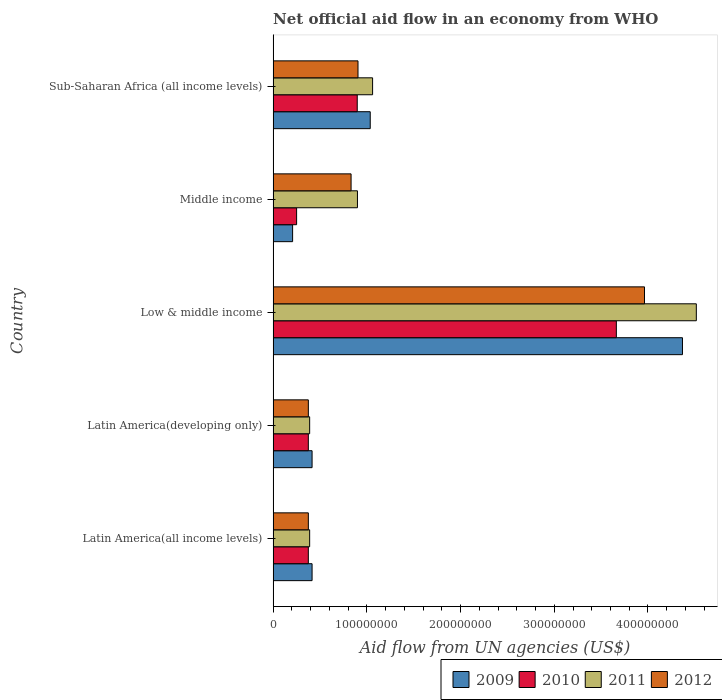How many groups of bars are there?
Offer a very short reply. 5. Are the number of bars per tick equal to the number of legend labels?
Your answer should be very brief. Yes. Are the number of bars on each tick of the Y-axis equal?
Your response must be concise. Yes. How many bars are there on the 2nd tick from the bottom?
Your response must be concise. 4. In how many cases, is the number of bars for a given country not equal to the number of legend labels?
Provide a short and direct response. 0. What is the net official aid flow in 2010 in Latin America(all income levels)?
Keep it short and to the point. 3.76e+07. Across all countries, what is the maximum net official aid flow in 2011?
Provide a short and direct response. 4.52e+08. Across all countries, what is the minimum net official aid flow in 2009?
Make the answer very short. 2.08e+07. In which country was the net official aid flow in 2012 maximum?
Provide a short and direct response. Low & middle income. In which country was the net official aid flow in 2011 minimum?
Provide a short and direct response. Latin America(all income levels). What is the total net official aid flow in 2009 in the graph?
Offer a very short reply. 6.44e+08. What is the difference between the net official aid flow in 2009 in Low & middle income and that in Middle income?
Ensure brevity in your answer.  4.16e+08. What is the difference between the net official aid flow in 2010 in Sub-Saharan Africa (all income levels) and the net official aid flow in 2012 in Middle income?
Offer a very short reply. 6.58e+06. What is the average net official aid flow in 2011 per country?
Give a very brief answer. 1.45e+08. What is the difference between the net official aid flow in 2010 and net official aid flow in 2009 in Latin America(developing only)?
Provide a short and direct response. -4.01e+06. In how many countries, is the net official aid flow in 2011 greater than 280000000 US$?
Keep it short and to the point. 1. What is the ratio of the net official aid flow in 2012 in Latin America(developing only) to that in Low & middle income?
Make the answer very short. 0.09. What is the difference between the highest and the second highest net official aid flow in 2011?
Make the answer very short. 3.45e+08. What is the difference between the highest and the lowest net official aid flow in 2012?
Provide a succinct answer. 3.59e+08. Are all the bars in the graph horizontal?
Ensure brevity in your answer.  Yes. What is the difference between two consecutive major ticks on the X-axis?
Your answer should be compact. 1.00e+08. Does the graph contain any zero values?
Offer a terse response. No. Does the graph contain grids?
Make the answer very short. No. Where does the legend appear in the graph?
Ensure brevity in your answer.  Bottom right. How are the legend labels stacked?
Your answer should be very brief. Horizontal. What is the title of the graph?
Provide a short and direct response. Net official aid flow in an economy from WHO. Does "1990" appear as one of the legend labels in the graph?
Your response must be concise. No. What is the label or title of the X-axis?
Offer a very short reply. Aid flow from UN agencies (US$). What is the Aid flow from UN agencies (US$) of 2009 in Latin America(all income levels)?
Offer a very short reply. 4.16e+07. What is the Aid flow from UN agencies (US$) in 2010 in Latin America(all income levels)?
Give a very brief answer. 3.76e+07. What is the Aid flow from UN agencies (US$) of 2011 in Latin America(all income levels)?
Offer a terse response. 3.90e+07. What is the Aid flow from UN agencies (US$) of 2012 in Latin America(all income levels)?
Make the answer very short. 3.76e+07. What is the Aid flow from UN agencies (US$) of 2009 in Latin America(developing only)?
Offer a very short reply. 4.16e+07. What is the Aid flow from UN agencies (US$) of 2010 in Latin America(developing only)?
Provide a succinct answer. 3.76e+07. What is the Aid flow from UN agencies (US$) in 2011 in Latin America(developing only)?
Ensure brevity in your answer.  3.90e+07. What is the Aid flow from UN agencies (US$) of 2012 in Latin America(developing only)?
Make the answer very short. 3.76e+07. What is the Aid flow from UN agencies (US$) in 2009 in Low & middle income?
Your answer should be compact. 4.37e+08. What is the Aid flow from UN agencies (US$) of 2010 in Low & middle income?
Provide a succinct answer. 3.66e+08. What is the Aid flow from UN agencies (US$) in 2011 in Low & middle income?
Offer a very short reply. 4.52e+08. What is the Aid flow from UN agencies (US$) of 2012 in Low & middle income?
Keep it short and to the point. 3.96e+08. What is the Aid flow from UN agencies (US$) in 2009 in Middle income?
Provide a succinct answer. 2.08e+07. What is the Aid flow from UN agencies (US$) of 2010 in Middle income?
Give a very brief answer. 2.51e+07. What is the Aid flow from UN agencies (US$) of 2011 in Middle income?
Provide a succinct answer. 9.00e+07. What is the Aid flow from UN agencies (US$) in 2012 in Middle income?
Keep it short and to the point. 8.32e+07. What is the Aid flow from UN agencies (US$) of 2009 in Sub-Saharan Africa (all income levels)?
Give a very brief answer. 1.04e+08. What is the Aid flow from UN agencies (US$) of 2010 in Sub-Saharan Africa (all income levels)?
Make the answer very short. 8.98e+07. What is the Aid flow from UN agencies (US$) of 2011 in Sub-Saharan Africa (all income levels)?
Keep it short and to the point. 1.06e+08. What is the Aid flow from UN agencies (US$) of 2012 in Sub-Saharan Africa (all income levels)?
Provide a succinct answer. 9.06e+07. Across all countries, what is the maximum Aid flow from UN agencies (US$) of 2009?
Offer a terse response. 4.37e+08. Across all countries, what is the maximum Aid flow from UN agencies (US$) in 2010?
Give a very brief answer. 3.66e+08. Across all countries, what is the maximum Aid flow from UN agencies (US$) of 2011?
Provide a succinct answer. 4.52e+08. Across all countries, what is the maximum Aid flow from UN agencies (US$) of 2012?
Offer a terse response. 3.96e+08. Across all countries, what is the minimum Aid flow from UN agencies (US$) in 2009?
Your response must be concise. 2.08e+07. Across all countries, what is the minimum Aid flow from UN agencies (US$) in 2010?
Your answer should be compact. 2.51e+07. Across all countries, what is the minimum Aid flow from UN agencies (US$) of 2011?
Your answer should be very brief. 3.90e+07. Across all countries, what is the minimum Aid flow from UN agencies (US$) in 2012?
Your answer should be very brief. 3.76e+07. What is the total Aid flow from UN agencies (US$) in 2009 in the graph?
Your response must be concise. 6.44e+08. What is the total Aid flow from UN agencies (US$) of 2010 in the graph?
Your response must be concise. 5.56e+08. What is the total Aid flow from UN agencies (US$) in 2011 in the graph?
Keep it short and to the point. 7.26e+08. What is the total Aid flow from UN agencies (US$) of 2012 in the graph?
Provide a short and direct response. 6.45e+08. What is the difference between the Aid flow from UN agencies (US$) of 2011 in Latin America(all income levels) and that in Latin America(developing only)?
Make the answer very short. 0. What is the difference between the Aid flow from UN agencies (US$) in 2009 in Latin America(all income levels) and that in Low & middle income?
Make the answer very short. -3.95e+08. What is the difference between the Aid flow from UN agencies (US$) of 2010 in Latin America(all income levels) and that in Low & middle income?
Your answer should be compact. -3.29e+08. What is the difference between the Aid flow from UN agencies (US$) of 2011 in Latin America(all income levels) and that in Low & middle income?
Your response must be concise. -4.13e+08. What is the difference between the Aid flow from UN agencies (US$) in 2012 in Latin America(all income levels) and that in Low & middle income?
Offer a terse response. -3.59e+08. What is the difference between the Aid flow from UN agencies (US$) of 2009 in Latin America(all income levels) and that in Middle income?
Your answer should be compact. 2.08e+07. What is the difference between the Aid flow from UN agencies (US$) of 2010 in Latin America(all income levels) and that in Middle income?
Provide a short and direct response. 1.25e+07. What is the difference between the Aid flow from UN agencies (US$) in 2011 in Latin America(all income levels) and that in Middle income?
Offer a terse response. -5.10e+07. What is the difference between the Aid flow from UN agencies (US$) in 2012 in Latin America(all income levels) and that in Middle income?
Your answer should be very brief. -4.56e+07. What is the difference between the Aid flow from UN agencies (US$) in 2009 in Latin America(all income levels) and that in Sub-Saharan Africa (all income levels)?
Offer a very short reply. -6.20e+07. What is the difference between the Aid flow from UN agencies (US$) in 2010 in Latin America(all income levels) and that in Sub-Saharan Africa (all income levels)?
Your answer should be very brief. -5.22e+07. What is the difference between the Aid flow from UN agencies (US$) in 2011 in Latin America(all income levels) and that in Sub-Saharan Africa (all income levels)?
Your answer should be compact. -6.72e+07. What is the difference between the Aid flow from UN agencies (US$) of 2012 in Latin America(all income levels) and that in Sub-Saharan Africa (all income levels)?
Your answer should be very brief. -5.30e+07. What is the difference between the Aid flow from UN agencies (US$) in 2009 in Latin America(developing only) and that in Low & middle income?
Provide a short and direct response. -3.95e+08. What is the difference between the Aid flow from UN agencies (US$) of 2010 in Latin America(developing only) and that in Low & middle income?
Keep it short and to the point. -3.29e+08. What is the difference between the Aid flow from UN agencies (US$) of 2011 in Latin America(developing only) and that in Low & middle income?
Offer a very short reply. -4.13e+08. What is the difference between the Aid flow from UN agencies (US$) in 2012 in Latin America(developing only) and that in Low & middle income?
Give a very brief answer. -3.59e+08. What is the difference between the Aid flow from UN agencies (US$) in 2009 in Latin America(developing only) and that in Middle income?
Keep it short and to the point. 2.08e+07. What is the difference between the Aid flow from UN agencies (US$) in 2010 in Latin America(developing only) and that in Middle income?
Provide a short and direct response. 1.25e+07. What is the difference between the Aid flow from UN agencies (US$) of 2011 in Latin America(developing only) and that in Middle income?
Provide a short and direct response. -5.10e+07. What is the difference between the Aid flow from UN agencies (US$) of 2012 in Latin America(developing only) and that in Middle income?
Offer a terse response. -4.56e+07. What is the difference between the Aid flow from UN agencies (US$) of 2009 in Latin America(developing only) and that in Sub-Saharan Africa (all income levels)?
Ensure brevity in your answer.  -6.20e+07. What is the difference between the Aid flow from UN agencies (US$) in 2010 in Latin America(developing only) and that in Sub-Saharan Africa (all income levels)?
Offer a terse response. -5.22e+07. What is the difference between the Aid flow from UN agencies (US$) in 2011 in Latin America(developing only) and that in Sub-Saharan Africa (all income levels)?
Offer a very short reply. -6.72e+07. What is the difference between the Aid flow from UN agencies (US$) in 2012 in Latin America(developing only) and that in Sub-Saharan Africa (all income levels)?
Provide a short and direct response. -5.30e+07. What is the difference between the Aid flow from UN agencies (US$) in 2009 in Low & middle income and that in Middle income?
Your answer should be very brief. 4.16e+08. What is the difference between the Aid flow from UN agencies (US$) of 2010 in Low & middle income and that in Middle income?
Give a very brief answer. 3.41e+08. What is the difference between the Aid flow from UN agencies (US$) in 2011 in Low & middle income and that in Middle income?
Give a very brief answer. 3.62e+08. What is the difference between the Aid flow from UN agencies (US$) of 2012 in Low & middle income and that in Middle income?
Your answer should be very brief. 3.13e+08. What is the difference between the Aid flow from UN agencies (US$) in 2009 in Low & middle income and that in Sub-Saharan Africa (all income levels)?
Offer a very short reply. 3.33e+08. What is the difference between the Aid flow from UN agencies (US$) in 2010 in Low & middle income and that in Sub-Saharan Africa (all income levels)?
Offer a very short reply. 2.76e+08. What is the difference between the Aid flow from UN agencies (US$) in 2011 in Low & middle income and that in Sub-Saharan Africa (all income levels)?
Your answer should be very brief. 3.45e+08. What is the difference between the Aid flow from UN agencies (US$) in 2012 in Low & middle income and that in Sub-Saharan Africa (all income levels)?
Ensure brevity in your answer.  3.06e+08. What is the difference between the Aid flow from UN agencies (US$) of 2009 in Middle income and that in Sub-Saharan Africa (all income levels)?
Your response must be concise. -8.28e+07. What is the difference between the Aid flow from UN agencies (US$) of 2010 in Middle income and that in Sub-Saharan Africa (all income levels)?
Offer a very short reply. -6.47e+07. What is the difference between the Aid flow from UN agencies (US$) in 2011 in Middle income and that in Sub-Saharan Africa (all income levels)?
Your response must be concise. -1.62e+07. What is the difference between the Aid flow from UN agencies (US$) in 2012 in Middle income and that in Sub-Saharan Africa (all income levels)?
Your answer should be very brief. -7.39e+06. What is the difference between the Aid flow from UN agencies (US$) in 2009 in Latin America(all income levels) and the Aid flow from UN agencies (US$) in 2010 in Latin America(developing only)?
Keep it short and to the point. 4.01e+06. What is the difference between the Aid flow from UN agencies (US$) of 2009 in Latin America(all income levels) and the Aid flow from UN agencies (US$) of 2011 in Latin America(developing only)?
Your answer should be very brief. 2.59e+06. What is the difference between the Aid flow from UN agencies (US$) of 2009 in Latin America(all income levels) and the Aid flow from UN agencies (US$) of 2012 in Latin America(developing only)?
Keep it short and to the point. 3.99e+06. What is the difference between the Aid flow from UN agencies (US$) of 2010 in Latin America(all income levels) and the Aid flow from UN agencies (US$) of 2011 in Latin America(developing only)?
Your answer should be very brief. -1.42e+06. What is the difference between the Aid flow from UN agencies (US$) in 2011 in Latin America(all income levels) and the Aid flow from UN agencies (US$) in 2012 in Latin America(developing only)?
Ensure brevity in your answer.  1.40e+06. What is the difference between the Aid flow from UN agencies (US$) in 2009 in Latin America(all income levels) and the Aid flow from UN agencies (US$) in 2010 in Low & middle income?
Your answer should be compact. -3.25e+08. What is the difference between the Aid flow from UN agencies (US$) of 2009 in Latin America(all income levels) and the Aid flow from UN agencies (US$) of 2011 in Low & middle income?
Keep it short and to the point. -4.10e+08. What is the difference between the Aid flow from UN agencies (US$) of 2009 in Latin America(all income levels) and the Aid flow from UN agencies (US$) of 2012 in Low & middle income?
Keep it short and to the point. -3.55e+08. What is the difference between the Aid flow from UN agencies (US$) in 2010 in Latin America(all income levels) and the Aid flow from UN agencies (US$) in 2011 in Low & middle income?
Ensure brevity in your answer.  -4.14e+08. What is the difference between the Aid flow from UN agencies (US$) of 2010 in Latin America(all income levels) and the Aid flow from UN agencies (US$) of 2012 in Low & middle income?
Keep it short and to the point. -3.59e+08. What is the difference between the Aid flow from UN agencies (US$) in 2011 in Latin America(all income levels) and the Aid flow from UN agencies (US$) in 2012 in Low & middle income?
Offer a very short reply. -3.57e+08. What is the difference between the Aid flow from UN agencies (US$) in 2009 in Latin America(all income levels) and the Aid flow from UN agencies (US$) in 2010 in Middle income?
Provide a succinct answer. 1.65e+07. What is the difference between the Aid flow from UN agencies (US$) of 2009 in Latin America(all income levels) and the Aid flow from UN agencies (US$) of 2011 in Middle income?
Your answer should be very brief. -4.84e+07. What is the difference between the Aid flow from UN agencies (US$) of 2009 in Latin America(all income levels) and the Aid flow from UN agencies (US$) of 2012 in Middle income?
Your answer should be compact. -4.16e+07. What is the difference between the Aid flow from UN agencies (US$) in 2010 in Latin America(all income levels) and the Aid flow from UN agencies (US$) in 2011 in Middle income?
Provide a succinct answer. -5.24e+07. What is the difference between the Aid flow from UN agencies (US$) in 2010 in Latin America(all income levels) and the Aid flow from UN agencies (US$) in 2012 in Middle income?
Your answer should be very brief. -4.56e+07. What is the difference between the Aid flow from UN agencies (US$) in 2011 in Latin America(all income levels) and the Aid flow from UN agencies (US$) in 2012 in Middle income?
Ensure brevity in your answer.  -4.42e+07. What is the difference between the Aid flow from UN agencies (US$) in 2009 in Latin America(all income levels) and the Aid flow from UN agencies (US$) in 2010 in Sub-Saharan Africa (all income levels)?
Your response must be concise. -4.82e+07. What is the difference between the Aid flow from UN agencies (US$) in 2009 in Latin America(all income levels) and the Aid flow from UN agencies (US$) in 2011 in Sub-Saharan Africa (all income levels)?
Your answer should be compact. -6.46e+07. What is the difference between the Aid flow from UN agencies (US$) in 2009 in Latin America(all income levels) and the Aid flow from UN agencies (US$) in 2012 in Sub-Saharan Africa (all income levels)?
Your answer should be very brief. -4.90e+07. What is the difference between the Aid flow from UN agencies (US$) in 2010 in Latin America(all income levels) and the Aid flow from UN agencies (US$) in 2011 in Sub-Saharan Africa (all income levels)?
Your answer should be very brief. -6.86e+07. What is the difference between the Aid flow from UN agencies (US$) in 2010 in Latin America(all income levels) and the Aid flow from UN agencies (US$) in 2012 in Sub-Saharan Africa (all income levels)?
Provide a short and direct response. -5.30e+07. What is the difference between the Aid flow from UN agencies (US$) of 2011 in Latin America(all income levels) and the Aid flow from UN agencies (US$) of 2012 in Sub-Saharan Africa (all income levels)?
Offer a terse response. -5.16e+07. What is the difference between the Aid flow from UN agencies (US$) of 2009 in Latin America(developing only) and the Aid flow from UN agencies (US$) of 2010 in Low & middle income?
Your response must be concise. -3.25e+08. What is the difference between the Aid flow from UN agencies (US$) of 2009 in Latin America(developing only) and the Aid flow from UN agencies (US$) of 2011 in Low & middle income?
Provide a succinct answer. -4.10e+08. What is the difference between the Aid flow from UN agencies (US$) in 2009 in Latin America(developing only) and the Aid flow from UN agencies (US$) in 2012 in Low & middle income?
Ensure brevity in your answer.  -3.55e+08. What is the difference between the Aid flow from UN agencies (US$) in 2010 in Latin America(developing only) and the Aid flow from UN agencies (US$) in 2011 in Low & middle income?
Give a very brief answer. -4.14e+08. What is the difference between the Aid flow from UN agencies (US$) of 2010 in Latin America(developing only) and the Aid flow from UN agencies (US$) of 2012 in Low & middle income?
Your answer should be very brief. -3.59e+08. What is the difference between the Aid flow from UN agencies (US$) of 2011 in Latin America(developing only) and the Aid flow from UN agencies (US$) of 2012 in Low & middle income?
Provide a short and direct response. -3.57e+08. What is the difference between the Aid flow from UN agencies (US$) of 2009 in Latin America(developing only) and the Aid flow from UN agencies (US$) of 2010 in Middle income?
Offer a very short reply. 1.65e+07. What is the difference between the Aid flow from UN agencies (US$) in 2009 in Latin America(developing only) and the Aid flow from UN agencies (US$) in 2011 in Middle income?
Your response must be concise. -4.84e+07. What is the difference between the Aid flow from UN agencies (US$) of 2009 in Latin America(developing only) and the Aid flow from UN agencies (US$) of 2012 in Middle income?
Provide a succinct answer. -4.16e+07. What is the difference between the Aid flow from UN agencies (US$) in 2010 in Latin America(developing only) and the Aid flow from UN agencies (US$) in 2011 in Middle income?
Provide a short and direct response. -5.24e+07. What is the difference between the Aid flow from UN agencies (US$) in 2010 in Latin America(developing only) and the Aid flow from UN agencies (US$) in 2012 in Middle income?
Your answer should be very brief. -4.56e+07. What is the difference between the Aid flow from UN agencies (US$) in 2011 in Latin America(developing only) and the Aid flow from UN agencies (US$) in 2012 in Middle income?
Provide a short and direct response. -4.42e+07. What is the difference between the Aid flow from UN agencies (US$) in 2009 in Latin America(developing only) and the Aid flow from UN agencies (US$) in 2010 in Sub-Saharan Africa (all income levels)?
Your response must be concise. -4.82e+07. What is the difference between the Aid flow from UN agencies (US$) in 2009 in Latin America(developing only) and the Aid flow from UN agencies (US$) in 2011 in Sub-Saharan Africa (all income levels)?
Keep it short and to the point. -6.46e+07. What is the difference between the Aid flow from UN agencies (US$) of 2009 in Latin America(developing only) and the Aid flow from UN agencies (US$) of 2012 in Sub-Saharan Africa (all income levels)?
Your response must be concise. -4.90e+07. What is the difference between the Aid flow from UN agencies (US$) of 2010 in Latin America(developing only) and the Aid flow from UN agencies (US$) of 2011 in Sub-Saharan Africa (all income levels)?
Keep it short and to the point. -6.86e+07. What is the difference between the Aid flow from UN agencies (US$) of 2010 in Latin America(developing only) and the Aid flow from UN agencies (US$) of 2012 in Sub-Saharan Africa (all income levels)?
Your answer should be compact. -5.30e+07. What is the difference between the Aid flow from UN agencies (US$) of 2011 in Latin America(developing only) and the Aid flow from UN agencies (US$) of 2012 in Sub-Saharan Africa (all income levels)?
Make the answer very short. -5.16e+07. What is the difference between the Aid flow from UN agencies (US$) in 2009 in Low & middle income and the Aid flow from UN agencies (US$) in 2010 in Middle income?
Provide a succinct answer. 4.12e+08. What is the difference between the Aid flow from UN agencies (US$) in 2009 in Low & middle income and the Aid flow from UN agencies (US$) in 2011 in Middle income?
Offer a very short reply. 3.47e+08. What is the difference between the Aid flow from UN agencies (US$) in 2009 in Low & middle income and the Aid flow from UN agencies (US$) in 2012 in Middle income?
Offer a very short reply. 3.54e+08. What is the difference between the Aid flow from UN agencies (US$) in 2010 in Low & middle income and the Aid flow from UN agencies (US$) in 2011 in Middle income?
Make the answer very short. 2.76e+08. What is the difference between the Aid flow from UN agencies (US$) in 2010 in Low & middle income and the Aid flow from UN agencies (US$) in 2012 in Middle income?
Offer a very short reply. 2.83e+08. What is the difference between the Aid flow from UN agencies (US$) in 2011 in Low & middle income and the Aid flow from UN agencies (US$) in 2012 in Middle income?
Offer a very short reply. 3.68e+08. What is the difference between the Aid flow from UN agencies (US$) of 2009 in Low & middle income and the Aid flow from UN agencies (US$) of 2010 in Sub-Saharan Africa (all income levels)?
Make the answer very short. 3.47e+08. What is the difference between the Aid flow from UN agencies (US$) in 2009 in Low & middle income and the Aid flow from UN agencies (US$) in 2011 in Sub-Saharan Africa (all income levels)?
Offer a very short reply. 3.31e+08. What is the difference between the Aid flow from UN agencies (US$) of 2009 in Low & middle income and the Aid flow from UN agencies (US$) of 2012 in Sub-Saharan Africa (all income levels)?
Ensure brevity in your answer.  3.46e+08. What is the difference between the Aid flow from UN agencies (US$) in 2010 in Low & middle income and the Aid flow from UN agencies (US$) in 2011 in Sub-Saharan Africa (all income levels)?
Your answer should be compact. 2.60e+08. What is the difference between the Aid flow from UN agencies (US$) in 2010 in Low & middle income and the Aid flow from UN agencies (US$) in 2012 in Sub-Saharan Africa (all income levels)?
Offer a terse response. 2.76e+08. What is the difference between the Aid flow from UN agencies (US$) of 2011 in Low & middle income and the Aid flow from UN agencies (US$) of 2012 in Sub-Saharan Africa (all income levels)?
Your answer should be very brief. 3.61e+08. What is the difference between the Aid flow from UN agencies (US$) of 2009 in Middle income and the Aid flow from UN agencies (US$) of 2010 in Sub-Saharan Africa (all income levels)?
Make the answer very short. -6.90e+07. What is the difference between the Aid flow from UN agencies (US$) in 2009 in Middle income and the Aid flow from UN agencies (US$) in 2011 in Sub-Saharan Africa (all income levels)?
Ensure brevity in your answer.  -8.54e+07. What is the difference between the Aid flow from UN agencies (US$) of 2009 in Middle income and the Aid flow from UN agencies (US$) of 2012 in Sub-Saharan Africa (all income levels)?
Ensure brevity in your answer.  -6.98e+07. What is the difference between the Aid flow from UN agencies (US$) of 2010 in Middle income and the Aid flow from UN agencies (US$) of 2011 in Sub-Saharan Africa (all income levels)?
Provide a short and direct response. -8.11e+07. What is the difference between the Aid flow from UN agencies (US$) of 2010 in Middle income and the Aid flow from UN agencies (US$) of 2012 in Sub-Saharan Africa (all income levels)?
Your answer should be very brief. -6.55e+07. What is the difference between the Aid flow from UN agencies (US$) of 2011 in Middle income and the Aid flow from UN agencies (US$) of 2012 in Sub-Saharan Africa (all income levels)?
Your answer should be compact. -5.90e+05. What is the average Aid flow from UN agencies (US$) of 2009 per country?
Make the answer very short. 1.29e+08. What is the average Aid flow from UN agencies (US$) in 2010 per country?
Make the answer very short. 1.11e+08. What is the average Aid flow from UN agencies (US$) in 2011 per country?
Your answer should be compact. 1.45e+08. What is the average Aid flow from UN agencies (US$) in 2012 per country?
Give a very brief answer. 1.29e+08. What is the difference between the Aid flow from UN agencies (US$) of 2009 and Aid flow from UN agencies (US$) of 2010 in Latin America(all income levels)?
Offer a terse response. 4.01e+06. What is the difference between the Aid flow from UN agencies (US$) in 2009 and Aid flow from UN agencies (US$) in 2011 in Latin America(all income levels)?
Provide a short and direct response. 2.59e+06. What is the difference between the Aid flow from UN agencies (US$) in 2009 and Aid flow from UN agencies (US$) in 2012 in Latin America(all income levels)?
Ensure brevity in your answer.  3.99e+06. What is the difference between the Aid flow from UN agencies (US$) in 2010 and Aid flow from UN agencies (US$) in 2011 in Latin America(all income levels)?
Offer a very short reply. -1.42e+06. What is the difference between the Aid flow from UN agencies (US$) of 2010 and Aid flow from UN agencies (US$) of 2012 in Latin America(all income levels)?
Provide a succinct answer. -2.00e+04. What is the difference between the Aid flow from UN agencies (US$) in 2011 and Aid flow from UN agencies (US$) in 2012 in Latin America(all income levels)?
Ensure brevity in your answer.  1.40e+06. What is the difference between the Aid flow from UN agencies (US$) in 2009 and Aid flow from UN agencies (US$) in 2010 in Latin America(developing only)?
Your response must be concise. 4.01e+06. What is the difference between the Aid flow from UN agencies (US$) of 2009 and Aid flow from UN agencies (US$) of 2011 in Latin America(developing only)?
Provide a short and direct response. 2.59e+06. What is the difference between the Aid flow from UN agencies (US$) in 2009 and Aid flow from UN agencies (US$) in 2012 in Latin America(developing only)?
Your response must be concise. 3.99e+06. What is the difference between the Aid flow from UN agencies (US$) in 2010 and Aid flow from UN agencies (US$) in 2011 in Latin America(developing only)?
Provide a short and direct response. -1.42e+06. What is the difference between the Aid flow from UN agencies (US$) of 2011 and Aid flow from UN agencies (US$) of 2012 in Latin America(developing only)?
Your answer should be compact. 1.40e+06. What is the difference between the Aid flow from UN agencies (US$) of 2009 and Aid flow from UN agencies (US$) of 2010 in Low & middle income?
Provide a short and direct response. 7.06e+07. What is the difference between the Aid flow from UN agencies (US$) in 2009 and Aid flow from UN agencies (US$) in 2011 in Low & middle income?
Keep it short and to the point. -1.48e+07. What is the difference between the Aid flow from UN agencies (US$) of 2009 and Aid flow from UN agencies (US$) of 2012 in Low & middle income?
Your answer should be very brief. 4.05e+07. What is the difference between the Aid flow from UN agencies (US$) in 2010 and Aid flow from UN agencies (US$) in 2011 in Low & middle income?
Keep it short and to the point. -8.54e+07. What is the difference between the Aid flow from UN agencies (US$) in 2010 and Aid flow from UN agencies (US$) in 2012 in Low & middle income?
Make the answer very short. -3.00e+07. What is the difference between the Aid flow from UN agencies (US$) of 2011 and Aid flow from UN agencies (US$) of 2012 in Low & middle income?
Provide a succinct answer. 5.53e+07. What is the difference between the Aid flow from UN agencies (US$) of 2009 and Aid flow from UN agencies (US$) of 2010 in Middle income?
Your response must be concise. -4.27e+06. What is the difference between the Aid flow from UN agencies (US$) of 2009 and Aid flow from UN agencies (US$) of 2011 in Middle income?
Your response must be concise. -6.92e+07. What is the difference between the Aid flow from UN agencies (US$) of 2009 and Aid flow from UN agencies (US$) of 2012 in Middle income?
Provide a succinct answer. -6.24e+07. What is the difference between the Aid flow from UN agencies (US$) in 2010 and Aid flow from UN agencies (US$) in 2011 in Middle income?
Make the answer very short. -6.49e+07. What is the difference between the Aid flow from UN agencies (US$) in 2010 and Aid flow from UN agencies (US$) in 2012 in Middle income?
Make the answer very short. -5.81e+07. What is the difference between the Aid flow from UN agencies (US$) of 2011 and Aid flow from UN agencies (US$) of 2012 in Middle income?
Keep it short and to the point. 6.80e+06. What is the difference between the Aid flow from UN agencies (US$) of 2009 and Aid flow from UN agencies (US$) of 2010 in Sub-Saharan Africa (all income levels)?
Offer a terse response. 1.39e+07. What is the difference between the Aid flow from UN agencies (US$) in 2009 and Aid flow from UN agencies (US$) in 2011 in Sub-Saharan Africa (all income levels)?
Your answer should be very brief. -2.53e+06. What is the difference between the Aid flow from UN agencies (US$) of 2009 and Aid flow from UN agencies (US$) of 2012 in Sub-Saharan Africa (all income levels)?
Make the answer very short. 1.30e+07. What is the difference between the Aid flow from UN agencies (US$) in 2010 and Aid flow from UN agencies (US$) in 2011 in Sub-Saharan Africa (all income levels)?
Your answer should be compact. -1.64e+07. What is the difference between the Aid flow from UN agencies (US$) of 2010 and Aid flow from UN agencies (US$) of 2012 in Sub-Saharan Africa (all income levels)?
Keep it short and to the point. -8.10e+05. What is the difference between the Aid flow from UN agencies (US$) in 2011 and Aid flow from UN agencies (US$) in 2012 in Sub-Saharan Africa (all income levels)?
Keep it short and to the point. 1.56e+07. What is the ratio of the Aid flow from UN agencies (US$) in 2012 in Latin America(all income levels) to that in Latin America(developing only)?
Make the answer very short. 1. What is the ratio of the Aid flow from UN agencies (US$) in 2009 in Latin America(all income levels) to that in Low & middle income?
Keep it short and to the point. 0.1. What is the ratio of the Aid flow from UN agencies (US$) in 2010 in Latin America(all income levels) to that in Low & middle income?
Your response must be concise. 0.1. What is the ratio of the Aid flow from UN agencies (US$) in 2011 in Latin America(all income levels) to that in Low & middle income?
Keep it short and to the point. 0.09. What is the ratio of the Aid flow from UN agencies (US$) in 2012 in Latin America(all income levels) to that in Low & middle income?
Provide a succinct answer. 0.09. What is the ratio of the Aid flow from UN agencies (US$) in 2009 in Latin America(all income levels) to that in Middle income?
Ensure brevity in your answer.  2. What is the ratio of the Aid flow from UN agencies (US$) in 2010 in Latin America(all income levels) to that in Middle income?
Provide a short and direct response. 1.5. What is the ratio of the Aid flow from UN agencies (US$) in 2011 in Latin America(all income levels) to that in Middle income?
Keep it short and to the point. 0.43. What is the ratio of the Aid flow from UN agencies (US$) of 2012 in Latin America(all income levels) to that in Middle income?
Your answer should be very brief. 0.45. What is the ratio of the Aid flow from UN agencies (US$) of 2009 in Latin America(all income levels) to that in Sub-Saharan Africa (all income levels)?
Provide a short and direct response. 0.4. What is the ratio of the Aid flow from UN agencies (US$) in 2010 in Latin America(all income levels) to that in Sub-Saharan Africa (all income levels)?
Give a very brief answer. 0.42. What is the ratio of the Aid flow from UN agencies (US$) in 2011 in Latin America(all income levels) to that in Sub-Saharan Africa (all income levels)?
Provide a succinct answer. 0.37. What is the ratio of the Aid flow from UN agencies (US$) of 2012 in Latin America(all income levels) to that in Sub-Saharan Africa (all income levels)?
Provide a short and direct response. 0.41. What is the ratio of the Aid flow from UN agencies (US$) in 2009 in Latin America(developing only) to that in Low & middle income?
Keep it short and to the point. 0.1. What is the ratio of the Aid flow from UN agencies (US$) of 2010 in Latin America(developing only) to that in Low & middle income?
Your response must be concise. 0.1. What is the ratio of the Aid flow from UN agencies (US$) in 2011 in Latin America(developing only) to that in Low & middle income?
Give a very brief answer. 0.09. What is the ratio of the Aid flow from UN agencies (US$) in 2012 in Latin America(developing only) to that in Low & middle income?
Provide a succinct answer. 0.09. What is the ratio of the Aid flow from UN agencies (US$) of 2009 in Latin America(developing only) to that in Middle income?
Offer a terse response. 2. What is the ratio of the Aid flow from UN agencies (US$) of 2010 in Latin America(developing only) to that in Middle income?
Provide a succinct answer. 1.5. What is the ratio of the Aid flow from UN agencies (US$) in 2011 in Latin America(developing only) to that in Middle income?
Provide a succinct answer. 0.43. What is the ratio of the Aid flow from UN agencies (US$) of 2012 in Latin America(developing only) to that in Middle income?
Your answer should be compact. 0.45. What is the ratio of the Aid flow from UN agencies (US$) in 2009 in Latin America(developing only) to that in Sub-Saharan Africa (all income levels)?
Your response must be concise. 0.4. What is the ratio of the Aid flow from UN agencies (US$) in 2010 in Latin America(developing only) to that in Sub-Saharan Africa (all income levels)?
Provide a succinct answer. 0.42. What is the ratio of the Aid flow from UN agencies (US$) in 2011 in Latin America(developing only) to that in Sub-Saharan Africa (all income levels)?
Keep it short and to the point. 0.37. What is the ratio of the Aid flow from UN agencies (US$) in 2012 in Latin America(developing only) to that in Sub-Saharan Africa (all income levels)?
Your answer should be very brief. 0.41. What is the ratio of the Aid flow from UN agencies (US$) of 2009 in Low & middle income to that in Middle income?
Provide a short and direct response. 21. What is the ratio of the Aid flow from UN agencies (US$) in 2010 in Low & middle income to that in Middle income?
Give a very brief answer. 14.61. What is the ratio of the Aid flow from UN agencies (US$) of 2011 in Low & middle income to that in Middle income?
Provide a succinct answer. 5.02. What is the ratio of the Aid flow from UN agencies (US$) of 2012 in Low & middle income to that in Middle income?
Offer a very short reply. 4.76. What is the ratio of the Aid flow from UN agencies (US$) in 2009 in Low & middle income to that in Sub-Saharan Africa (all income levels)?
Your answer should be very brief. 4.22. What is the ratio of the Aid flow from UN agencies (US$) of 2010 in Low & middle income to that in Sub-Saharan Africa (all income levels)?
Your answer should be compact. 4.08. What is the ratio of the Aid flow from UN agencies (US$) of 2011 in Low & middle income to that in Sub-Saharan Africa (all income levels)?
Provide a succinct answer. 4.25. What is the ratio of the Aid flow from UN agencies (US$) of 2012 in Low & middle income to that in Sub-Saharan Africa (all income levels)?
Your response must be concise. 4.38. What is the ratio of the Aid flow from UN agencies (US$) of 2009 in Middle income to that in Sub-Saharan Africa (all income levels)?
Make the answer very short. 0.2. What is the ratio of the Aid flow from UN agencies (US$) of 2010 in Middle income to that in Sub-Saharan Africa (all income levels)?
Provide a short and direct response. 0.28. What is the ratio of the Aid flow from UN agencies (US$) in 2011 in Middle income to that in Sub-Saharan Africa (all income levels)?
Provide a short and direct response. 0.85. What is the ratio of the Aid flow from UN agencies (US$) of 2012 in Middle income to that in Sub-Saharan Africa (all income levels)?
Offer a terse response. 0.92. What is the difference between the highest and the second highest Aid flow from UN agencies (US$) of 2009?
Give a very brief answer. 3.33e+08. What is the difference between the highest and the second highest Aid flow from UN agencies (US$) in 2010?
Your answer should be very brief. 2.76e+08. What is the difference between the highest and the second highest Aid flow from UN agencies (US$) of 2011?
Your answer should be very brief. 3.45e+08. What is the difference between the highest and the second highest Aid flow from UN agencies (US$) of 2012?
Your answer should be compact. 3.06e+08. What is the difference between the highest and the lowest Aid flow from UN agencies (US$) of 2009?
Give a very brief answer. 4.16e+08. What is the difference between the highest and the lowest Aid flow from UN agencies (US$) of 2010?
Your answer should be very brief. 3.41e+08. What is the difference between the highest and the lowest Aid flow from UN agencies (US$) in 2011?
Your answer should be compact. 4.13e+08. What is the difference between the highest and the lowest Aid flow from UN agencies (US$) of 2012?
Offer a terse response. 3.59e+08. 